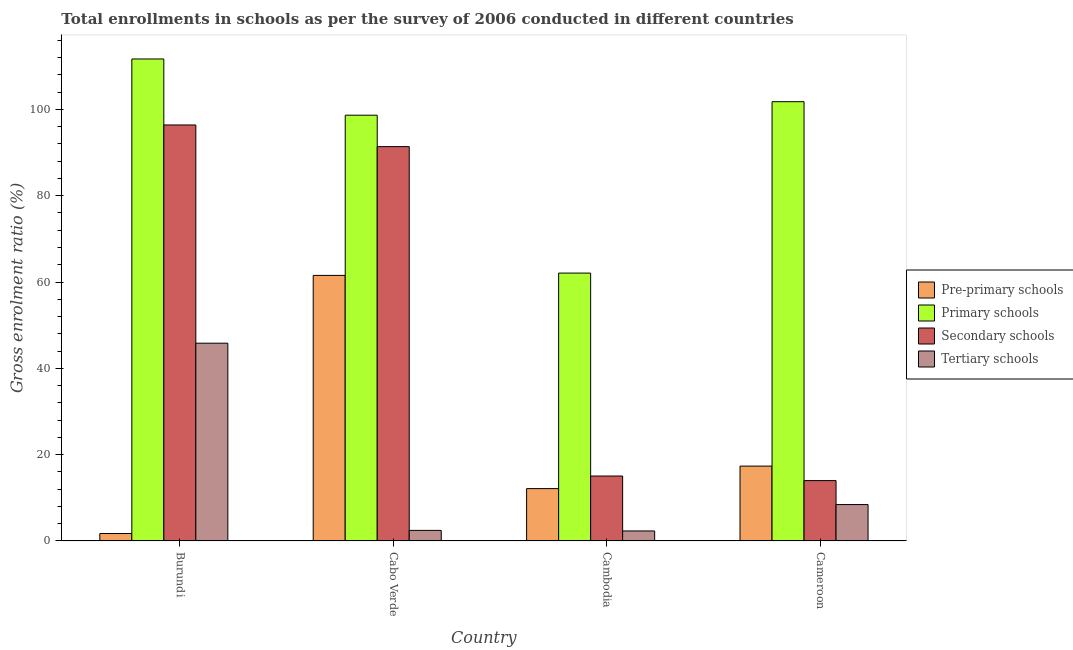How many different coloured bars are there?
Offer a very short reply. 4. Are the number of bars per tick equal to the number of legend labels?
Ensure brevity in your answer.  Yes. How many bars are there on the 2nd tick from the left?
Provide a succinct answer. 4. What is the label of the 2nd group of bars from the left?
Give a very brief answer. Cabo Verde. In how many cases, is the number of bars for a given country not equal to the number of legend labels?
Offer a terse response. 0. What is the gross enrolment ratio in tertiary schools in Burundi?
Your response must be concise. 45.82. Across all countries, what is the maximum gross enrolment ratio in pre-primary schools?
Offer a terse response. 61.53. Across all countries, what is the minimum gross enrolment ratio in tertiary schools?
Keep it short and to the point. 2.31. In which country was the gross enrolment ratio in pre-primary schools maximum?
Keep it short and to the point. Cabo Verde. In which country was the gross enrolment ratio in pre-primary schools minimum?
Ensure brevity in your answer.  Burundi. What is the total gross enrolment ratio in pre-primary schools in the graph?
Your response must be concise. 92.71. What is the difference between the gross enrolment ratio in secondary schools in Burundi and that in Cameroon?
Give a very brief answer. 82.41. What is the difference between the gross enrolment ratio in primary schools in Cambodia and the gross enrolment ratio in pre-primary schools in Burundi?
Offer a terse response. 60.35. What is the average gross enrolment ratio in secondary schools per country?
Give a very brief answer. 54.2. What is the difference between the gross enrolment ratio in pre-primary schools and gross enrolment ratio in tertiary schools in Burundi?
Your answer should be very brief. -44.1. In how many countries, is the gross enrolment ratio in secondary schools greater than 8 %?
Your response must be concise. 4. What is the ratio of the gross enrolment ratio in secondary schools in Burundi to that in Cabo Verde?
Ensure brevity in your answer.  1.05. Is the gross enrolment ratio in pre-primary schools in Burundi less than that in Cambodia?
Your answer should be compact. Yes. Is the difference between the gross enrolment ratio in tertiary schools in Cabo Verde and Cameroon greater than the difference between the gross enrolment ratio in pre-primary schools in Cabo Verde and Cameroon?
Make the answer very short. No. What is the difference between the highest and the second highest gross enrolment ratio in tertiary schools?
Provide a short and direct response. 37.4. What is the difference between the highest and the lowest gross enrolment ratio in pre-primary schools?
Your response must be concise. 59.81. In how many countries, is the gross enrolment ratio in secondary schools greater than the average gross enrolment ratio in secondary schools taken over all countries?
Your answer should be compact. 2. What does the 4th bar from the left in Burundi represents?
Your response must be concise. Tertiary schools. What does the 2nd bar from the right in Cabo Verde represents?
Provide a short and direct response. Secondary schools. How many bars are there?
Ensure brevity in your answer.  16. Are the values on the major ticks of Y-axis written in scientific E-notation?
Offer a terse response. No. Does the graph contain any zero values?
Your answer should be compact. No. Does the graph contain grids?
Offer a very short reply. No. Where does the legend appear in the graph?
Provide a succinct answer. Center right. What is the title of the graph?
Ensure brevity in your answer.  Total enrollments in schools as per the survey of 2006 conducted in different countries. What is the label or title of the Y-axis?
Your answer should be compact. Gross enrolment ratio (%). What is the Gross enrolment ratio (%) of Pre-primary schools in Burundi?
Make the answer very short. 1.72. What is the Gross enrolment ratio (%) in Primary schools in Burundi?
Your response must be concise. 111.68. What is the Gross enrolment ratio (%) in Secondary schools in Burundi?
Offer a terse response. 96.39. What is the Gross enrolment ratio (%) of Tertiary schools in Burundi?
Ensure brevity in your answer.  45.82. What is the Gross enrolment ratio (%) of Pre-primary schools in Cabo Verde?
Provide a succinct answer. 61.53. What is the Gross enrolment ratio (%) in Primary schools in Cabo Verde?
Your answer should be compact. 98.66. What is the Gross enrolment ratio (%) in Secondary schools in Cabo Verde?
Make the answer very short. 91.37. What is the Gross enrolment ratio (%) of Tertiary schools in Cabo Verde?
Your answer should be compact. 2.44. What is the Gross enrolment ratio (%) in Pre-primary schools in Cambodia?
Your response must be concise. 12.13. What is the Gross enrolment ratio (%) in Primary schools in Cambodia?
Keep it short and to the point. 62.07. What is the Gross enrolment ratio (%) of Secondary schools in Cambodia?
Your answer should be very brief. 15.04. What is the Gross enrolment ratio (%) in Tertiary schools in Cambodia?
Keep it short and to the point. 2.31. What is the Gross enrolment ratio (%) in Pre-primary schools in Cameroon?
Your answer should be very brief. 17.34. What is the Gross enrolment ratio (%) of Primary schools in Cameroon?
Give a very brief answer. 101.78. What is the Gross enrolment ratio (%) of Secondary schools in Cameroon?
Offer a terse response. 13.98. What is the Gross enrolment ratio (%) in Tertiary schools in Cameroon?
Offer a very short reply. 8.42. Across all countries, what is the maximum Gross enrolment ratio (%) of Pre-primary schools?
Your answer should be very brief. 61.53. Across all countries, what is the maximum Gross enrolment ratio (%) in Primary schools?
Offer a very short reply. 111.68. Across all countries, what is the maximum Gross enrolment ratio (%) of Secondary schools?
Provide a succinct answer. 96.39. Across all countries, what is the maximum Gross enrolment ratio (%) of Tertiary schools?
Provide a succinct answer. 45.82. Across all countries, what is the minimum Gross enrolment ratio (%) in Pre-primary schools?
Provide a short and direct response. 1.72. Across all countries, what is the minimum Gross enrolment ratio (%) in Primary schools?
Offer a very short reply. 62.07. Across all countries, what is the minimum Gross enrolment ratio (%) of Secondary schools?
Keep it short and to the point. 13.98. Across all countries, what is the minimum Gross enrolment ratio (%) in Tertiary schools?
Keep it short and to the point. 2.31. What is the total Gross enrolment ratio (%) in Pre-primary schools in the graph?
Your answer should be very brief. 92.71. What is the total Gross enrolment ratio (%) in Primary schools in the graph?
Ensure brevity in your answer.  374.19. What is the total Gross enrolment ratio (%) of Secondary schools in the graph?
Make the answer very short. 216.78. What is the total Gross enrolment ratio (%) of Tertiary schools in the graph?
Keep it short and to the point. 59. What is the difference between the Gross enrolment ratio (%) in Pre-primary schools in Burundi and that in Cabo Verde?
Give a very brief answer. -59.81. What is the difference between the Gross enrolment ratio (%) in Primary schools in Burundi and that in Cabo Verde?
Ensure brevity in your answer.  13.03. What is the difference between the Gross enrolment ratio (%) of Secondary schools in Burundi and that in Cabo Verde?
Offer a terse response. 5.02. What is the difference between the Gross enrolment ratio (%) of Tertiary schools in Burundi and that in Cabo Verde?
Make the answer very short. 43.38. What is the difference between the Gross enrolment ratio (%) of Pre-primary schools in Burundi and that in Cambodia?
Keep it short and to the point. -10.41. What is the difference between the Gross enrolment ratio (%) in Primary schools in Burundi and that in Cambodia?
Provide a short and direct response. 49.62. What is the difference between the Gross enrolment ratio (%) in Secondary schools in Burundi and that in Cambodia?
Make the answer very short. 81.35. What is the difference between the Gross enrolment ratio (%) in Tertiary schools in Burundi and that in Cambodia?
Ensure brevity in your answer.  43.51. What is the difference between the Gross enrolment ratio (%) of Pre-primary schools in Burundi and that in Cameroon?
Make the answer very short. -15.62. What is the difference between the Gross enrolment ratio (%) in Primary schools in Burundi and that in Cameroon?
Offer a very short reply. 9.9. What is the difference between the Gross enrolment ratio (%) in Secondary schools in Burundi and that in Cameroon?
Make the answer very short. 82.41. What is the difference between the Gross enrolment ratio (%) in Tertiary schools in Burundi and that in Cameroon?
Your answer should be compact. 37.4. What is the difference between the Gross enrolment ratio (%) of Pre-primary schools in Cabo Verde and that in Cambodia?
Keep it short and to the point. 49.41. What is the difference between the Gross enrolment ratio (%) of Primary schools in Cabo Verde and that in Cambodia?
Offer a terse response. 36.59. What is the difference between the Gross enrolment ratio (%) of Secondary schools in Cabo Verde and that in Cambodia?
Your answer should be compact. 76.33. What is the difference between the Gross enrolment ratio (%) of Tertiary schools in Cabo Verde and that in Cambodia?
Provide a succinct answer. 0.13. What is the difference between the Gross enrolment ratio (%) of Pre-primary schools in Cabo Verde and that in Cameroon?
Provide a short and direct response. 44.19. What is the difference between the Gross enrolment ratio (%) in Primary schools in Cabo Verde and that in Cameroon?
Provide a short and direct response. -3.13. What is the difference between the Gross enrolment ratio (%) in Secondary schools in Cabo Verde and that in Cameroon?
Make the answer very short. 77.39. What is the difference between the Gross enrolment ratio (%) of Tertiary schools in Cabo Verde and that in Cameroon?
Give a very brief answer. -5.98. What is the difference between the Gross enrolment ratio (%) of Pre-primary schools in Cambodia and that in Cameroon?
Offer a very short reply. -5.21. What is the difference between the Gross enrolment ratio (%) of Primary schools in Cambodia and that in Cameroon?
Provide a succinct answer. -39.72. What is the difference between the Gross enrolment ratio (%) in Secondary schools in Cambodia and that in Cameroon?
Keep it short and to the point. 1.06. What is the difference between the Gross enrolment ratio (%) of Tertiary schools in Cambodia and that in Cameroon?
Keep it short and to the point. -6.11. What is the difference between the Gross enrolment ratio (%) in Pre-primary schools in Burundi and the Gross enrolment ratio (%) in Primary schools in Cabo Verde?
Keep it short and to the point. -96.94. What is the difference between the Gross enrolment ratio (%) of Pre-primary schools in Burundi and the Gross enrolment ratio (%) of Secondary schools in Cabo Verde?
Your answer should be compact. -89.65. What is the difference between the Gross enrolment ratio (%) in Pre-primary schools in Burundi and the Gross enrolment ratio (%) in Tertiary schools in Cabo Verde?
Keep it short and to the point. -0.72. What is the difference between the Gross enrolment ratio (%) of Primary schools in Burundi and the Gross enrolment ratio (%) of Secondary schools in Cabo Verde?
Provide a succinct answer. 20.31. What is the difference between the Gross enrolment ratio (%) of Primary schools in Burundi and the Gross enrolment ratio (%) of Tertiary schools in Cabo Verde?
Your answer should be very brief. 109.24. What is the difference between the Gross enrolment ratio (%) in Secondary schools in Burundi and the Gross enrolment ratio (%) in Tertiary schools in Cabo Verde?
Make the answer very short. 93.95. What is the difference between the Gross enrolment ratio (%) in Pre-primary schools in Burundi and the Gross enrolment ratio (%) in Primary schools in Cambodia?
Your answer should be very brief. -60.35. What is the difference between the Gross enrolment ratio (%) of Pre-primary schools in Burundi and the Gross enrolment ratio (%) of Secondary schools in Cambodia?
Your answer should be very brief. -13.32. What is the difference between the Gross enrolment ratio (%) of Pre-primary schools in Burundi and the Gross enrolment ratio (%) of Tertiary schools in Cambodia?
Give a very brief answer. -0.6. What is the difference between the Gross enrolment ratio (%) of Primary schools in Burundi and the Gross enrolment ratio (%) of Secondary schools in Cambodia?
Your answer should be compact. 96.64. What is the difference between the Gross enrolment ratio (%) in Primary schools in Burundi and the Gross enrolment ratio (%) in Tertiary schools in Cambodia?
Keep it short and to the point. 109.37. What is the difference between the Gross enrolment ratio (%) of Secondary schools in Burundi and the Gross enrolment ratio (%) of Tertiary schools in Cambodia?
Make the answer very short. 94.08. What is the difference between the Gross enrolment ratio (%) of Pre-primary schools in Burundi and the Gross enrolment ratio (%) of Primary schools in Cameroon?
Provide a short and direct response. -100.07. What is the difference between the Gross enrolment ratio (%) of Pre-primary schools in Burundi and the Gross enrolment ratio (%) of Secondary schools in Cameroon?
Offer a very short reply. -12.26. What is the difference between the Gross enrolment ratio (%) of Pre-primary schools in Burundi and the Gross enrolment ratio (%) of Tertiary schools in Cameroon?
Ensure brevity in your answer.  -6.71. What is the difference between the Gross enrolment ratio (%) of Primary schools in Burundi and the Gross enrolment ratio (%) of Secondary schools in Cameroon?
Your answer should be very brief. 97.7. What is the difference between the Gross enrolment ratio (%) in Primary schools in Burundi and the Gross enrolment ratio (%) in Tertiary schools in Cameroon?
Keep it short and to the point. 103.26. What is the difference between the Gross enrolment ratio (%) in Secondary schools in Burundi and the Gross enrolment ratio (%) in Tertiary schools in Cameroon?
Offer a terse response. 87.97. What is the difference between the Gross enrolment ratio (%) of Pre-primary schools in Cabo Verde and the Gross enrolment ratio (%) of Primary schools in Cambodia?
Give a very brief answer. -0.53. What is the difference between the Gross enrolment ratio (%) of Pre-primary schools in Cabo Verde and the Gross enrolment ratio (%) of Secondary schools in Cambodia?
Your answer should be very brief. 46.49. What is the difference between the Gross enrolment ratio (%) of Pre-primary schools in Cabo Verde and the Gross enrolment ratio (%) of Tertiary schools in Cambodia?
Your response must be concise. 59.22. What is the difference between the Gross enrolment ratio (%) in Primary schools in Cabo Verde and the Gross enrolment ratio (%) in Secondary schools in Cambodia?
Provide a short and direct response. 83.62. What is the difference between the Gross enrolment ratio (%) of Primary schools in Cabo Verde and the Gross enrolment ratio (%) of Tertiary schools in Cambodia?
Your answer should be compact. 96.34. What is the difference between the Gross enrolment ratio (%) of Secondary schools in Cabo Verde and the Gross enrolment ratio (%) of Tertiary schools in Cambodia?
Keep it short and to the point. 89.06. What is the difference between the Gross enrolment ratio (%) of Pre-primary schools in Cabo Verde and the Gross enrolment ratio (%) of Primary schools in Cameroon?
Your response must be concise. -40.25. What is the difference between the Gross enrolment ratio (%) of Pre-primary schools in Cabo Verde and the Gross enrolment ratio (%) of Secondary schools in Cameroon?
Keep it short and to the point. 47.55. What is the difference between the Gross enrolment ratio (%) of Pre-primary schools in Cabo Verde and the Gross enrolment ratio (%) of Tertiary schools in Cameroon?
Give a very brief answer. 53.11. What is the difference between the Gross enrolment ratio (%) in Primary schools in Cabo Verde and the Gross enrolment ratio (%) in Secondary schools in Cameroon?
Give a very brief answer. 84.68. What is the difference between the Gross enrolment ratio (%) in Primary schools in Cabo Verde and the Gross enrolment ratio (%) in Tertiary schools in Cameroon?
Make the answer very short. 90.23. What is the difference between the Gross enrolment ratio (%) of Secondary schools in Cabo Verde and the Gross enrolment ratio (%) of Tertiary schools in Cameroon?
Your response must be concise. 82.95. What is the difference between the Gross enrolment ratio (%) of Pre-primary schools in Cambodia and the Gross enrolment ratio (%) of Primary schools in Cameroon?
Your response must be concise. -89.66. What is the difference between the Gross enrolment ratio (%) in Pre-primary schools in Cambodia and the Gross enrolment ratio (%) in Secondary schools in Cameroon?
Provide a short and direct response. -1.86. What is the difference between the Gross enrolment ratio (%) in Pre-primary schools in Cambodia and the Gross enrolment ratio (%) in Tertiary schools in Cameroon?
Provide a succinct answer. 3.7. What is the difference between the Gross enrolment ratio (%) in Primary schools in Cambodia and the Gross enrolment ratio (%) in Secondary schools in Cameroon?
Your answer should be compact. 48.08. What is the difference between the Gross enrolment ratio (%) of Primary schools in Cambodia and the Gross enrolment ratio (%) of Tertiary schools in Cameroon?
Your response must be concise. 53.64. What is the difference between the Gross enrolment ratio (%) of Secondary schools in Cambodia and the Gross enrolment ratio (%) of Tertiary schools in Cameroon?
Keep it short and to the point. 6.62. What is the average Gross enrolment ratio (%) of Pre-primary schools per country?
Keep it short and to the point. 23.18. What is the average Gross enrolment ratio (%) of Primary schools per country?
Offer a terse response. 93.55. What is the average Gross enrolment ratio (%) of Secondary schools per country?
Provide a short and direct response. 54.2. What is the average Gross enrolment ratio (%) in Tertiary schools per country?
Provide a short and direct response. 14.75. What is the difference between the Gross enrolment ratio (%) in Pre-primary schools and Gross enrolment ratio (%) in Primary schools in Burundi?
Give a very brief answer. -109.97. What is the difference between the Gross enrolment ratio (%) of Pre-primary schools and Gross enrolment ratio (%) of Secondary schools in Burundi?
Make the answer very short. -94.68. What is the difference between the Gross enrolment ratio (%) of Pre-primary schools and Gross enrolment ratio (%) of Tertiary schools in Burundi?
Offer a very short reply. -44.1. What is the difference between the Gross enrolment ratio (%) of Primary schools and Gross enrolment ratio (%) of Secondary schools in Burundi?
Your response must be concise. 15.29. What is the difference between the Gross enrolment ratio (%) in Primary schools and Gross enrolment ratio (%) in Tertiary schools in Burundi?
Provide a succinct answer. 65.86. What is the difference between the Gross enrolment ratio (%) of Secondary schools and Gross enrolment ratio (%) of Tertiary schools in Burundi?
Provide a succinct answer. 50.57. What is the difference between the Gross enrolment ratio (%) in Pre-primary schools and Gross enrolment ratio (%) in Primary schools in Cabo Verde?
Your answer should be compact. -37.12. What is the difference between the Gross enrolment ratio (%) of Pre-primary schools and Gross enrolment ratio (%) of Secondary schools in Cabo Verde?
Offer a very short reply. -29.84. What is the difference between the Gross enrolment ratio (%) of Pre-primary schools and Gross enrolment ratio (%) of Tertiary schools in Cabo Verde?
Give a very brief answer. 59.09. What is the difference between the Gross enrolment ratio (%) of Primary schools and Gross enrolment ratio (%) of Secondary schools in Cabo Verde?
Offer a terse response. 7.29. What is the difference between the Gross enrolment ratio (%) in Primary schools and Gross enrolment ratio (%) in Tertiary schools in Cabo Verde?
Ensure brevity in your answer.  96.21. What is the difference between the Gross enrolment ratio (%) in Secondary schools and Gross enrolment ratio (%) in Tertiary schools in Cabo Verde?
Keep it short and to the point. 88.93. What is the difference between the Gross enrolment ratio (%) of Pre-primary schools and Gross enrolment ratio (%) of Primary schools in Cambodia?
Offer a very short reply. -49.94. What is the difference between the Gross enrolment ratio (%) of Pre-primary schools and Gross enrolment ratio (%) of Secondary schools in Cambodia?
Keep it short and to the point. -2.92. What is the difference between the Gross enrolment ratio (%) in Pre-primary schools and Gross enrolment ratio (%) in Tertiary schools in Cambodia?
Your response must be concise. 9.81. What is the difference between the Gross enrolment ratio (%) of Primary schools and Gross enrolment ratio (%) of Secondary schools in Cambodia?
Offer a terse response. 47.02. What is the difference between the Gross enrolment ratio (%) of Primary schools and Gross enrolment ratio (%) of Tertiary schools in Cambodia?
Keep it short and to the point. 59.75. What is the difference between the Gross enrolment ratio (%) in Secondary schools and Gross enrolment ratio (%) in Tertiary schools in Cambodia?
Make the answer very short. 12.73. What is the difference between the Gross enrolment ratio (%) in Pre-primary schools and Gross enrolment ratio (%) in Primary schools in Cameroon?
Provide a succinct answer. -84.44. What is the difference between the Gross enrolment ratio (%) of Pre-primary schools and Gross enrolment ratio (%) of Secondary schools in Cameroon?
Your answer should be very brief. 3.36. What is the difference between the Gross enrolment ratio (%) in Pre-primary schools and Gross enrolment ratio (%) in Tertiary schools in Cameroon?
Offer a terse response. 8.91. What is the difference between the Gross enrolment ratio (%) in Primary schools and Gross enrolment ratio (%) in Secondary schools in Cameroon?
Offer a terse response. 87.8. What is the difference between the Gross enrolment ratio (%) in Primary schools and Gross enrolment ratio (%) in Tertiary schools in Cameroon?
Give a very brief answer. 93.36. What is the difference between the Gross enrolment ratio (%) in Secondary schools and Gross enrolment ratio (%) in Tertiary schools in Cameroon?
Offer a very short reply. 5.56. What is the ratio of the Gross enrolment ratio (%) of Pre-primary schools in Burundi to that in Cabo Verde?
Make the answer very short. 0.03. What is the ratio of the Gross enrolment ratio (%) of Primary schools in Burundi to that in Cabo Verde?
Your response must be concise. 1.13. What is the ratio of the Gross enrolment ratio (%) of Secondary schools in Burundi to that in Cabo Verde?
Your answer should be compact. 1.05. What is the ratio of the Gross enrolment ratio (%) in Tertiary schools in Burundi to that in Cabo Verde?
Provide a succinct answer. 18.77. What is the ratio of the Gross enrolment ratio (%) of Pre-primary schools in Burundi to that in Cambodia?
Make the answer very short. 0.14. What is the ratio of the Gross enrolment ratio (%) in Primary schools in Burundi to that in Cambodia?
Give a very brief answer. 1.8. What is the ratio of the Gross enrolment ratio (%) in Secondary schools in Burundi to that in Cambodia?
Your answer should be very brief. 6.41. What is the ratio of the Gross enrolment ratio (%) in Tertiary schools in Burundi to that in Cambodia?
Provide a succinct answer. 19.82. What is the ratio of the Gross enrolment ratio (%) of Pre-primary schools in Burundi to that in Cameroon?
Ensure brevity in your answer.  0.1. What is the ratio of the Gross enrolment ratio (%) of Primary schools in Burundi to that in Cameroon?
Ensure brevity in your answer.  1.1. What is the ratio of the Gross enrolment ratio (%) in Secondary schools in Burundi to that in Cameroon?
Your response must be concise. 6.89. What is the ratio of the Gross enrolment ratio (%) of Tertiary schools in Burundi to that in Cameroon?
Give a very brief answer. 5.44. What is the ratio of the Gross enrolment ratio (%) of Pre-primary schools in Cabo Verde to that in Cambodia?
Keep it short and to the point. 5.07. What is the ratio of the Gross enrolment ratio (%) of Primary schools in Cabo Verde to that in Cambodia?
Offer a very short reply. 1.59. What is the ratio of the Gross enrolment ratio (%) of Secondary schools in Cabo Verde to that in Cambodia?
Make the answer very short. 6.07. What is the ratio of the Gross enrolment ratio (%) in Tertiary schools in Cabo Verde to that in Cambodia?
Ensure brevity in your answer.  1.06. What is the ratio of the Gross enrolment ratio (%) in Pre-primary schools in Cabo Verde to that in Cameroon?
Make the answer very short. 3.55. What is the ratio of the Gross enrolment ratio (%) of Primary schools in Cabo Verde to that in Cameroon?
Your answer should be very brief. 0.97. What is the ratio of the Gross enrolment ratio (%) in Secondary schools in Cabo Verde to that in Cameroon?
Provide a succinct answer. 6.54. What is the ratio of the Gross enrolment ratio (%) of Tertiary schools in Cabo Verde to that in Cameroon?
Your answer should be compact. 0.29. What is the ratio of the Gross enrolment ratio (%) of Pre-primary schools in Cambodia to that in Cameroon?
Keep it short and to the point. 0.7. What is the ratio of the Gross enrolment ratio (%) in Primary schools in Cambodia to that in Cameroon?
Offer a terse response. 0.61. What is the ratio of the Gross enrolment ratio (%) of Secondary schools in Cambodia to that in Cameroon?
Offer a very short reply. 1.08. What is the ratio of the Gross enrolment ratio (%) in Tertiary schools in Cambodia to that in Cameroon?
Offer a terse response. 0.27. What is the difference between the highest and the second highest Gross enrolment ratio (%) of Pre-primary schools?
Provide a succinct answer. 44.19. What is the difference between the highest and the second highest Gross enrolment ratio (%) in Primary schools?
Provide a short and direct response. 9.9. What is the difference between the highest and the second highest Gross enrolment ratio (%) in Secondary schools?
Your answer should be very brief. 5.02. What is the difference between the highest and the second highest Gross enrolment ratio (%) of Tertiary schools?
Give a very brief answer. 37.4. What is the difference between the highest and the lowest Gross enrolment ratio (%) in Pre-primary schools?
Make the answer very short. 59.81. What is the difference between the highest and the lowest Gross enrolment ratio (%) of Primary schools?
Your answer should be compact. 49.62. What is the difference between the highest and the lowest Gross enrolment ratio (%) in Secondary schools?
Keep it short and to the point. 82.41. What is the difference between the highest and the lowest Gross enrolment ratio (%) in Tertiary schools?
Your answer should be very brief. 43.51. 